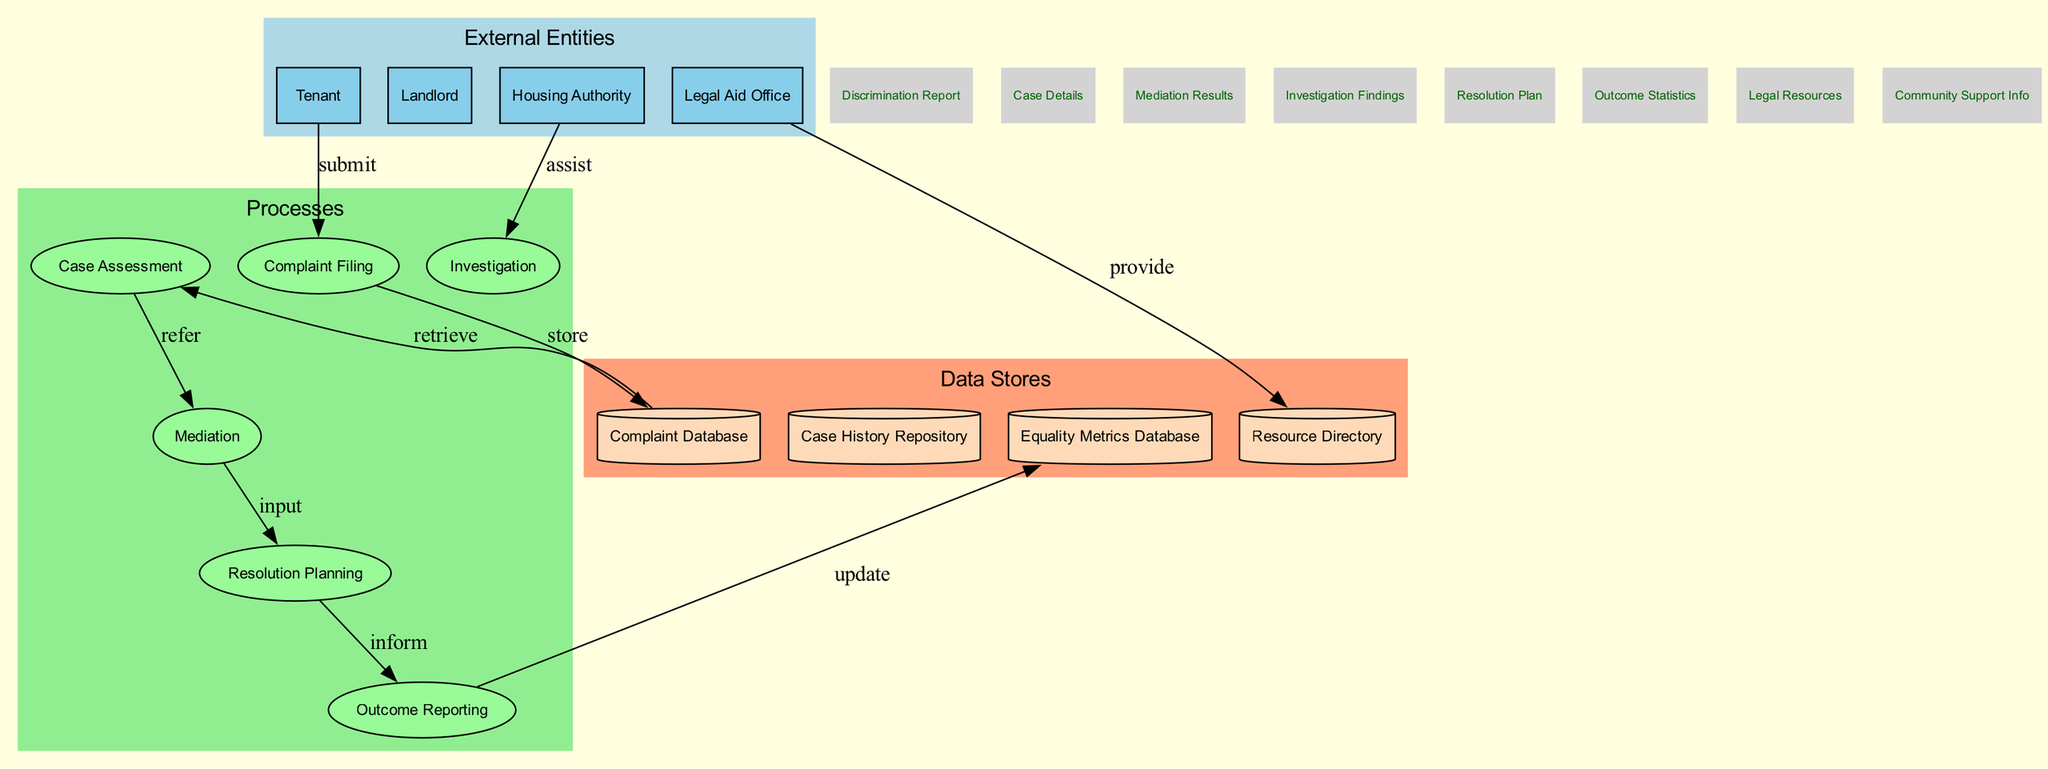What are the external entities involved? The diagram explicitly lists four external entities: Tenant, Landlord, Housing Authority, and Legal Aid Office. These are represented in their own compartment indicating their role as sources or recipients of data in the system.
Answer: Tenant, Landlord, Housing Authority, Legal Aid Office How many processes are depicted in the diagram? There are six processes shown within the diagram: Complaint Filing, Case Assessment, Mediation, Investigation, Resolution Planning, and Outcome Reporting. Counting these components shows a total of six distinct processes involved in the workflow.
Answer: 6 Which process follows the Complaint Filing? The arrow from Complaint Filing leads directly to Case Assessment, indicating that this is the immediate next step in the data flow after a complaint has been filed.
Answer: Case Assessment What data flow originates from the Mediation process? The Mediation process is connected to the Resolution Planning process. Therefore, the direct data flow that moves from Mediation represents the input of mediation results into the subsequent resolution planning phase.
Answer: Mediation Results How does the Housing Authority interact with the investigation process? The Housing Authority provides assistance to the Investigation process. This relationship is indicated by a directed edge connecting these entities, signifying that the Housing Authority plays a supportive role in investigations related to complaints.
Answer: assist What is the purpose of the Equality Metrics Database in the context of the diagram? The Resolution Planning process updates the Equality Metrics Database as a final outcome. This means that the findings or details of the resolution plans are intended to be recorded to monitor fairness and equality in housing-related issues.
Answer: update What is the role of the Legal Aid Office in the workflow? The Legal Aid Office provides resources, as indicated by its connection to the Resource Directory. This means it plays a crucial role by supplying legal resources that tenants might need during the housing dispute process.
Answer: provide Which data store holds case details? The connections suggest that the Case Assessment process retrieves information from the Complaint Database, indicating that this data store holds details regarding cases that have been filed so far.
Answer: Complaint Database How many data stores are presented in the diagram? The diagram includes four distinct data stores: Complaint Database, Case History Repository, Equality Metrics Database, and Resource Directory. By counting these storage elements, we find that there are four data stores involved in the system.
Answer: 4 